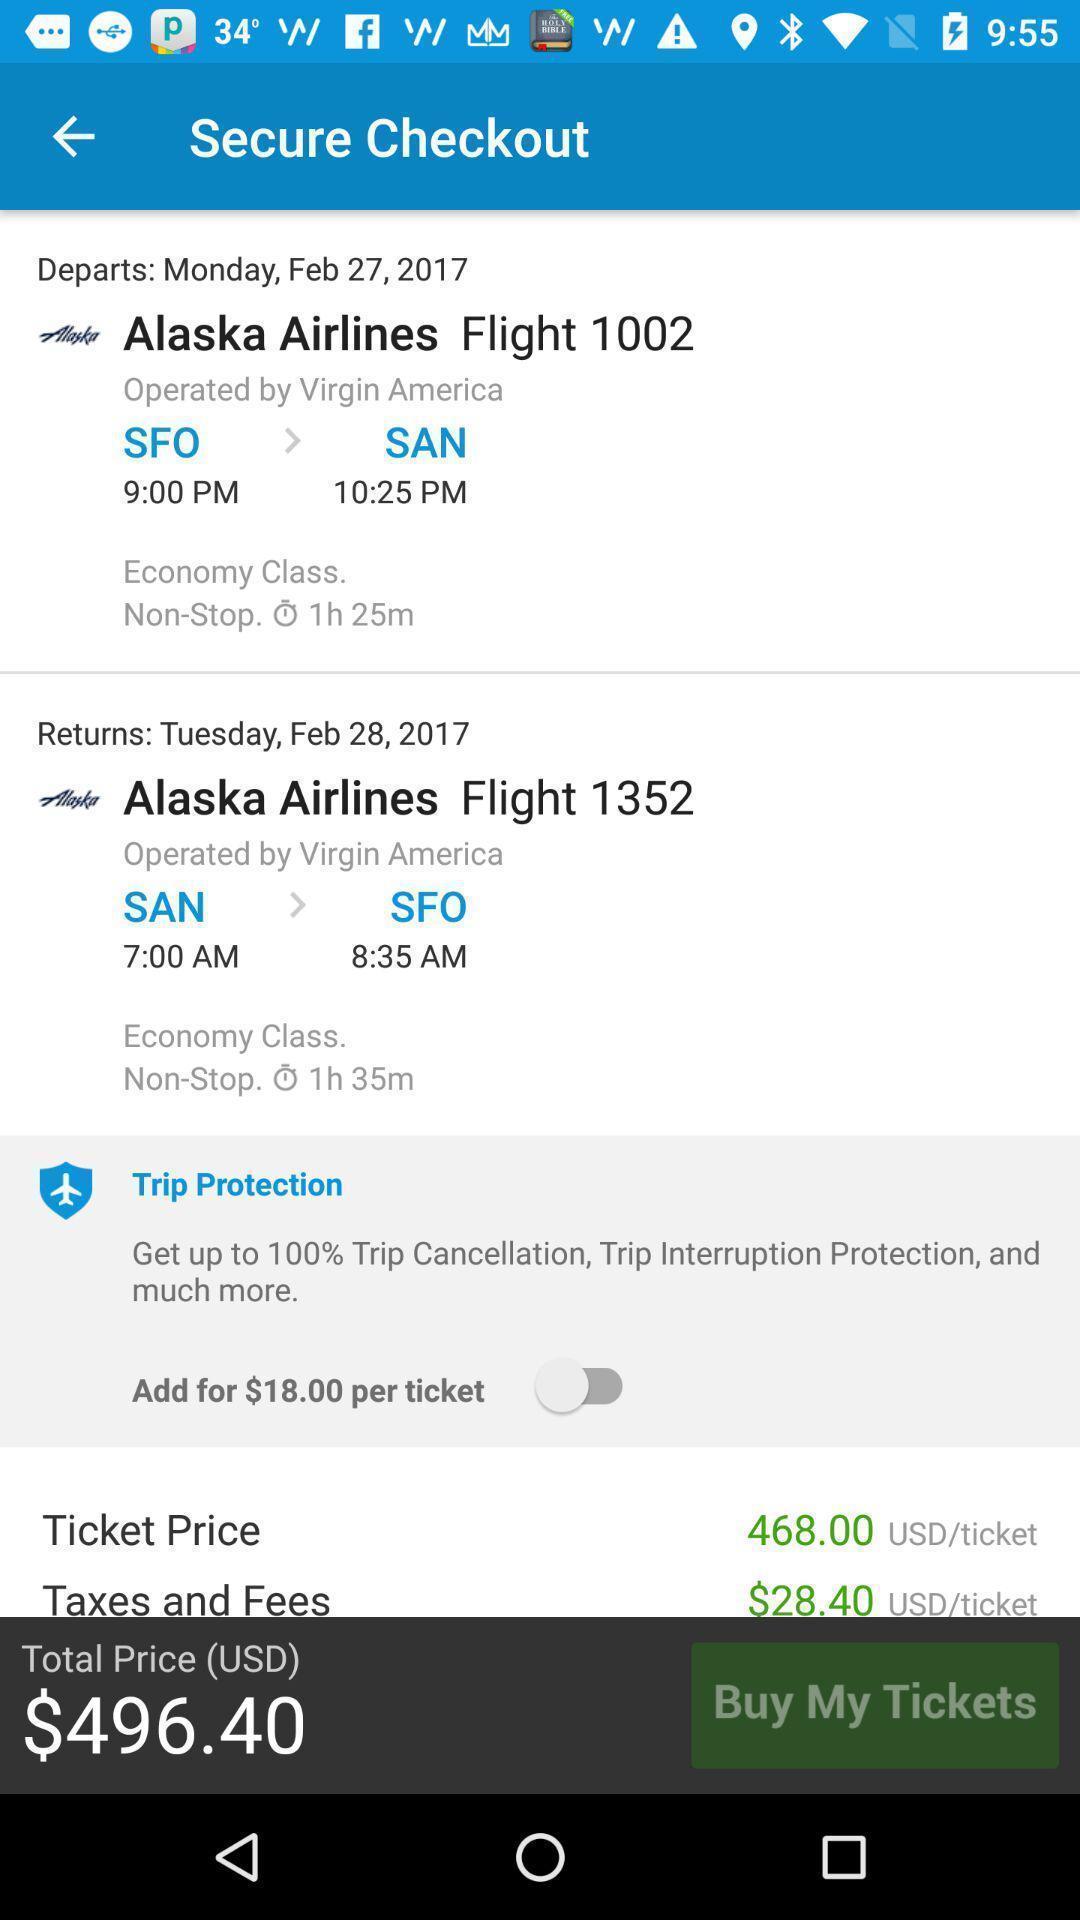Tell me about the visual elements in this screen capture. Screen shows secure checkout details in a travel app. 